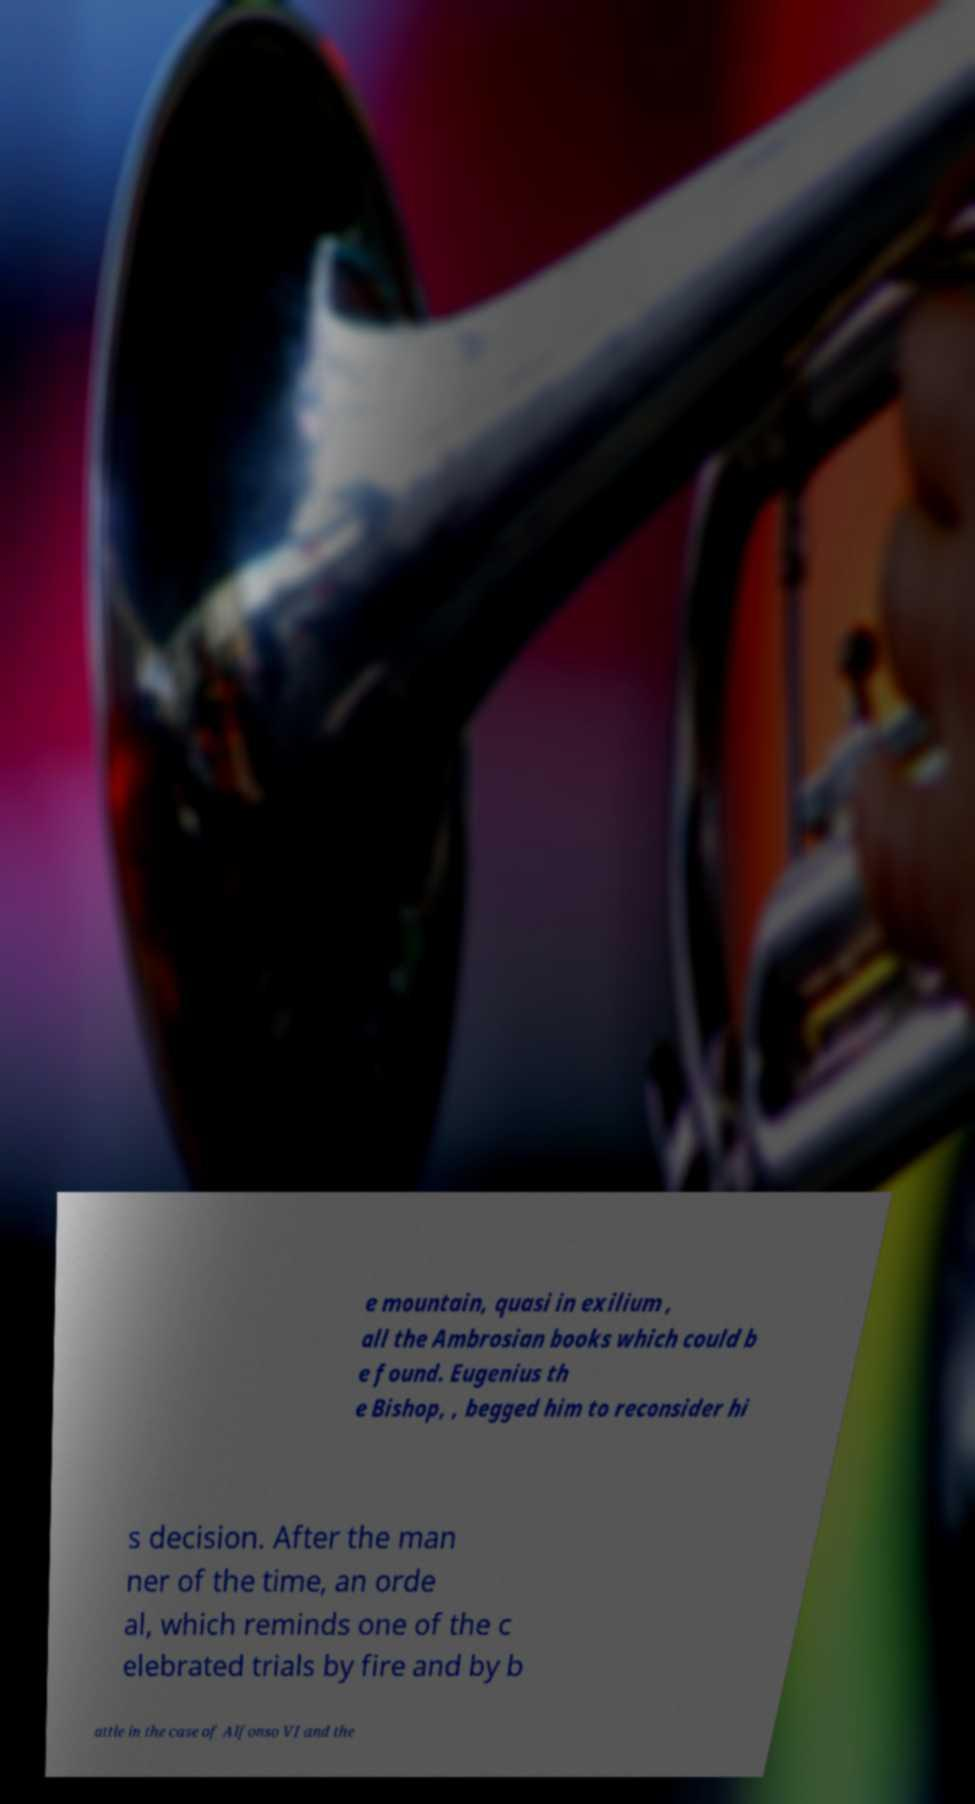Can you read and provide the text displayed in the image?This photo seems to have some interesting text. Can you extract and type it out for me? e mountain, quasi in exilium , all the Ambrosian books which could b e found. Eugenius th e Bishop, , begged him to reconsider hi s decision. After the man ner of the time, an orde al, which reminds one of the c elebrated trials by fire and by b attle in the case of Alfonso VI and the 